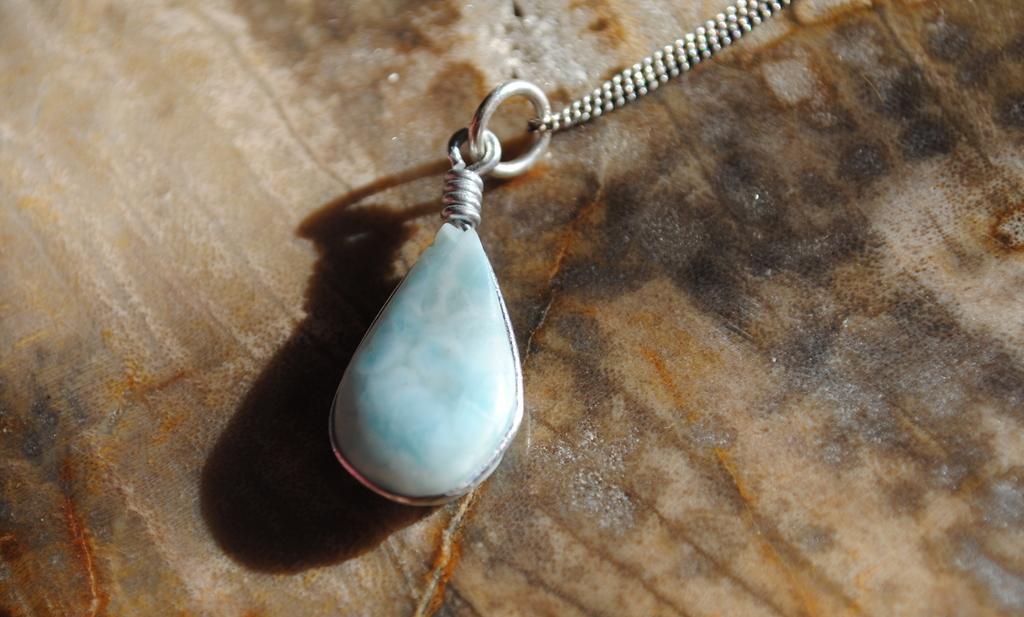Please provide a concise description of this image. In this image I see a blue color thing to this chain and this chain is on a brown and black color surface. 